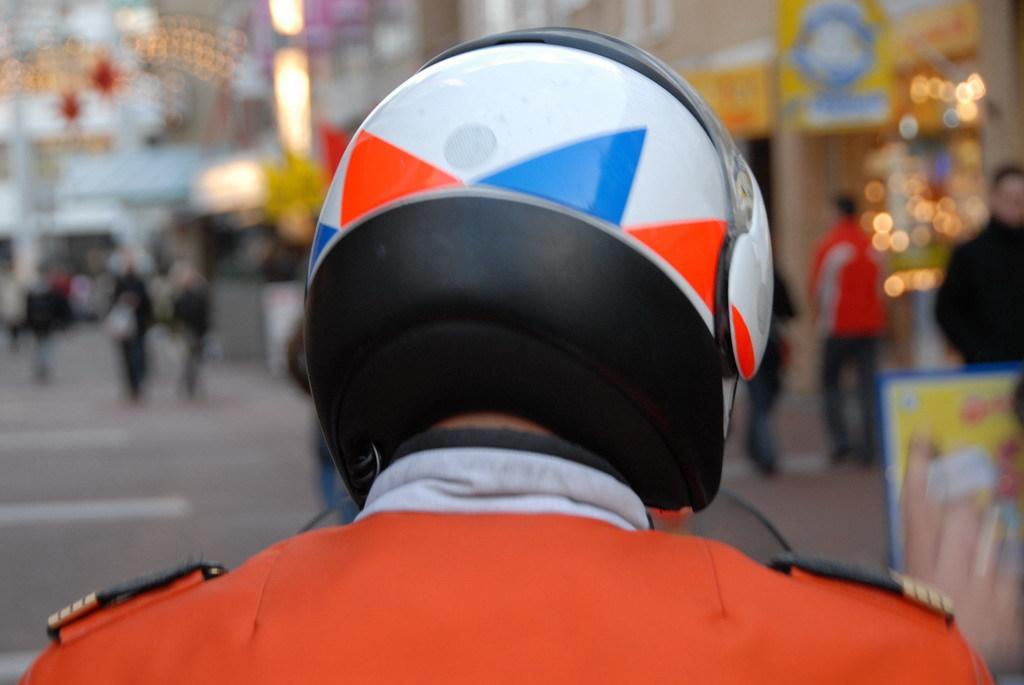Could you give a brief overview of what you see in this image? This image is taken outdoors. In this image the background is a little blurred. There are a few boards. There are a few lights. There are a few buildings. A few people are walking on the road. There are a few rope lights. In the middle of the image there is a person with a helmet on the head. 